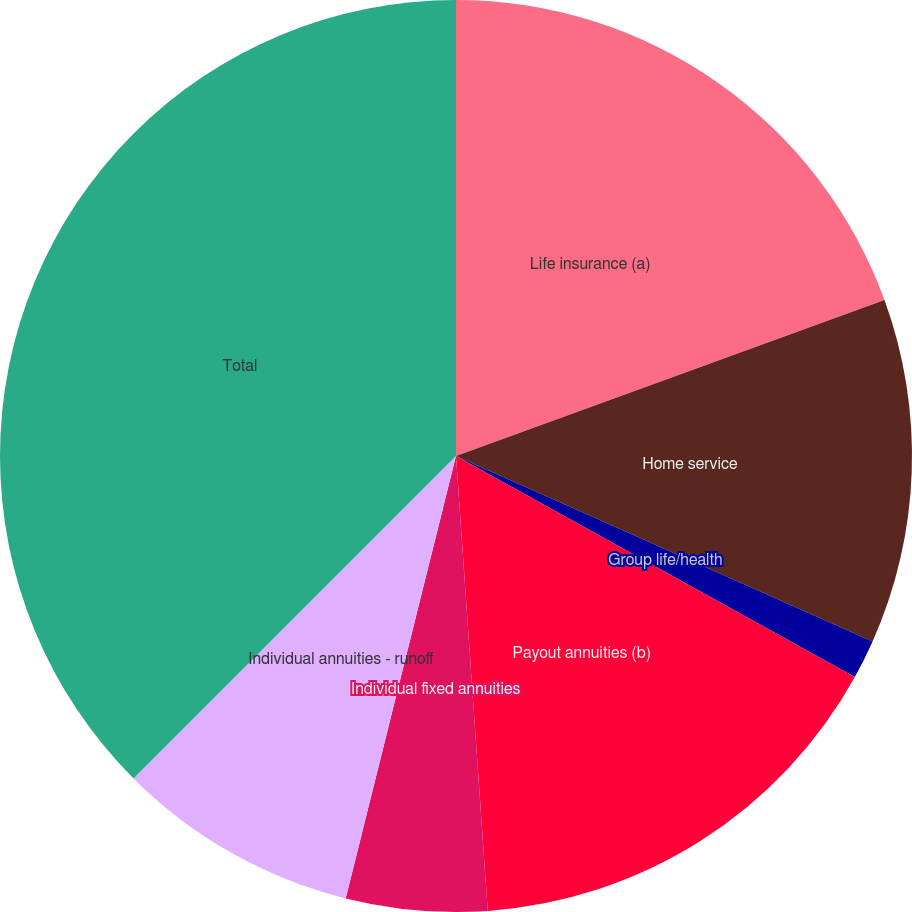Convert chart. <chart><loc_0><loc_0><loc_500><loc_500><pie_chart><fcel>Life insurance (a)<fcel>Home service<fcel>Group life/health<fcel>Payout annuities (b)<fcel>Individual fixed annuities<fcel>Individual annuities - runoff<fcel>Total<nl><fcel>19.44%<fcel>12.22%<fcel>1.39%<fcel>15.83%<fcel>5.0%<fcel>8.61%<fcel>37.49%<nl></chart> 